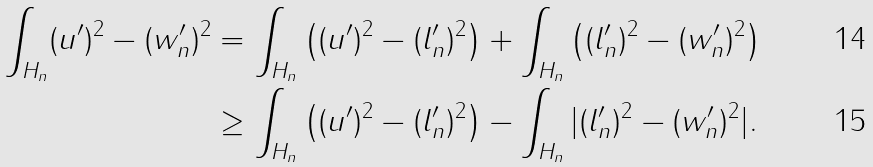<formula> <loc_0><loc_0><loc_500><loc_500>\int _ { H _ { n } } ( u ^ { \prime } ) ^ { 2 } - ( w _ { n } ^ { \prime } ) ^ { 2 } & = \int _ { H _ { n } } \left ( ( u ^ { \prime } ) ^ { 2 } - ( l _ { n } ^ { \prime } ) ^ { 2 } \right ) + \int _ { H _ { n } } \left ( ( l _ { n } ^ { \prime } ) ^ { 2 } - ( w _ { n } ^ { \prime } ) ^ { 2 } \right ) \\ & \geq \int _ { H _ { n } } \left ( ( u ^ { \prime } ) ^ { 2 } - ( l _ { n } ^ { \prime } ) ^ { 2 } \right ) - \int _ { H _ { n } } | ( l _ { n } ^ { \prime } ) ^ { 2 } - ( w _ { n } ^ { \prime } ) ^ { 2 } | .</formula> 